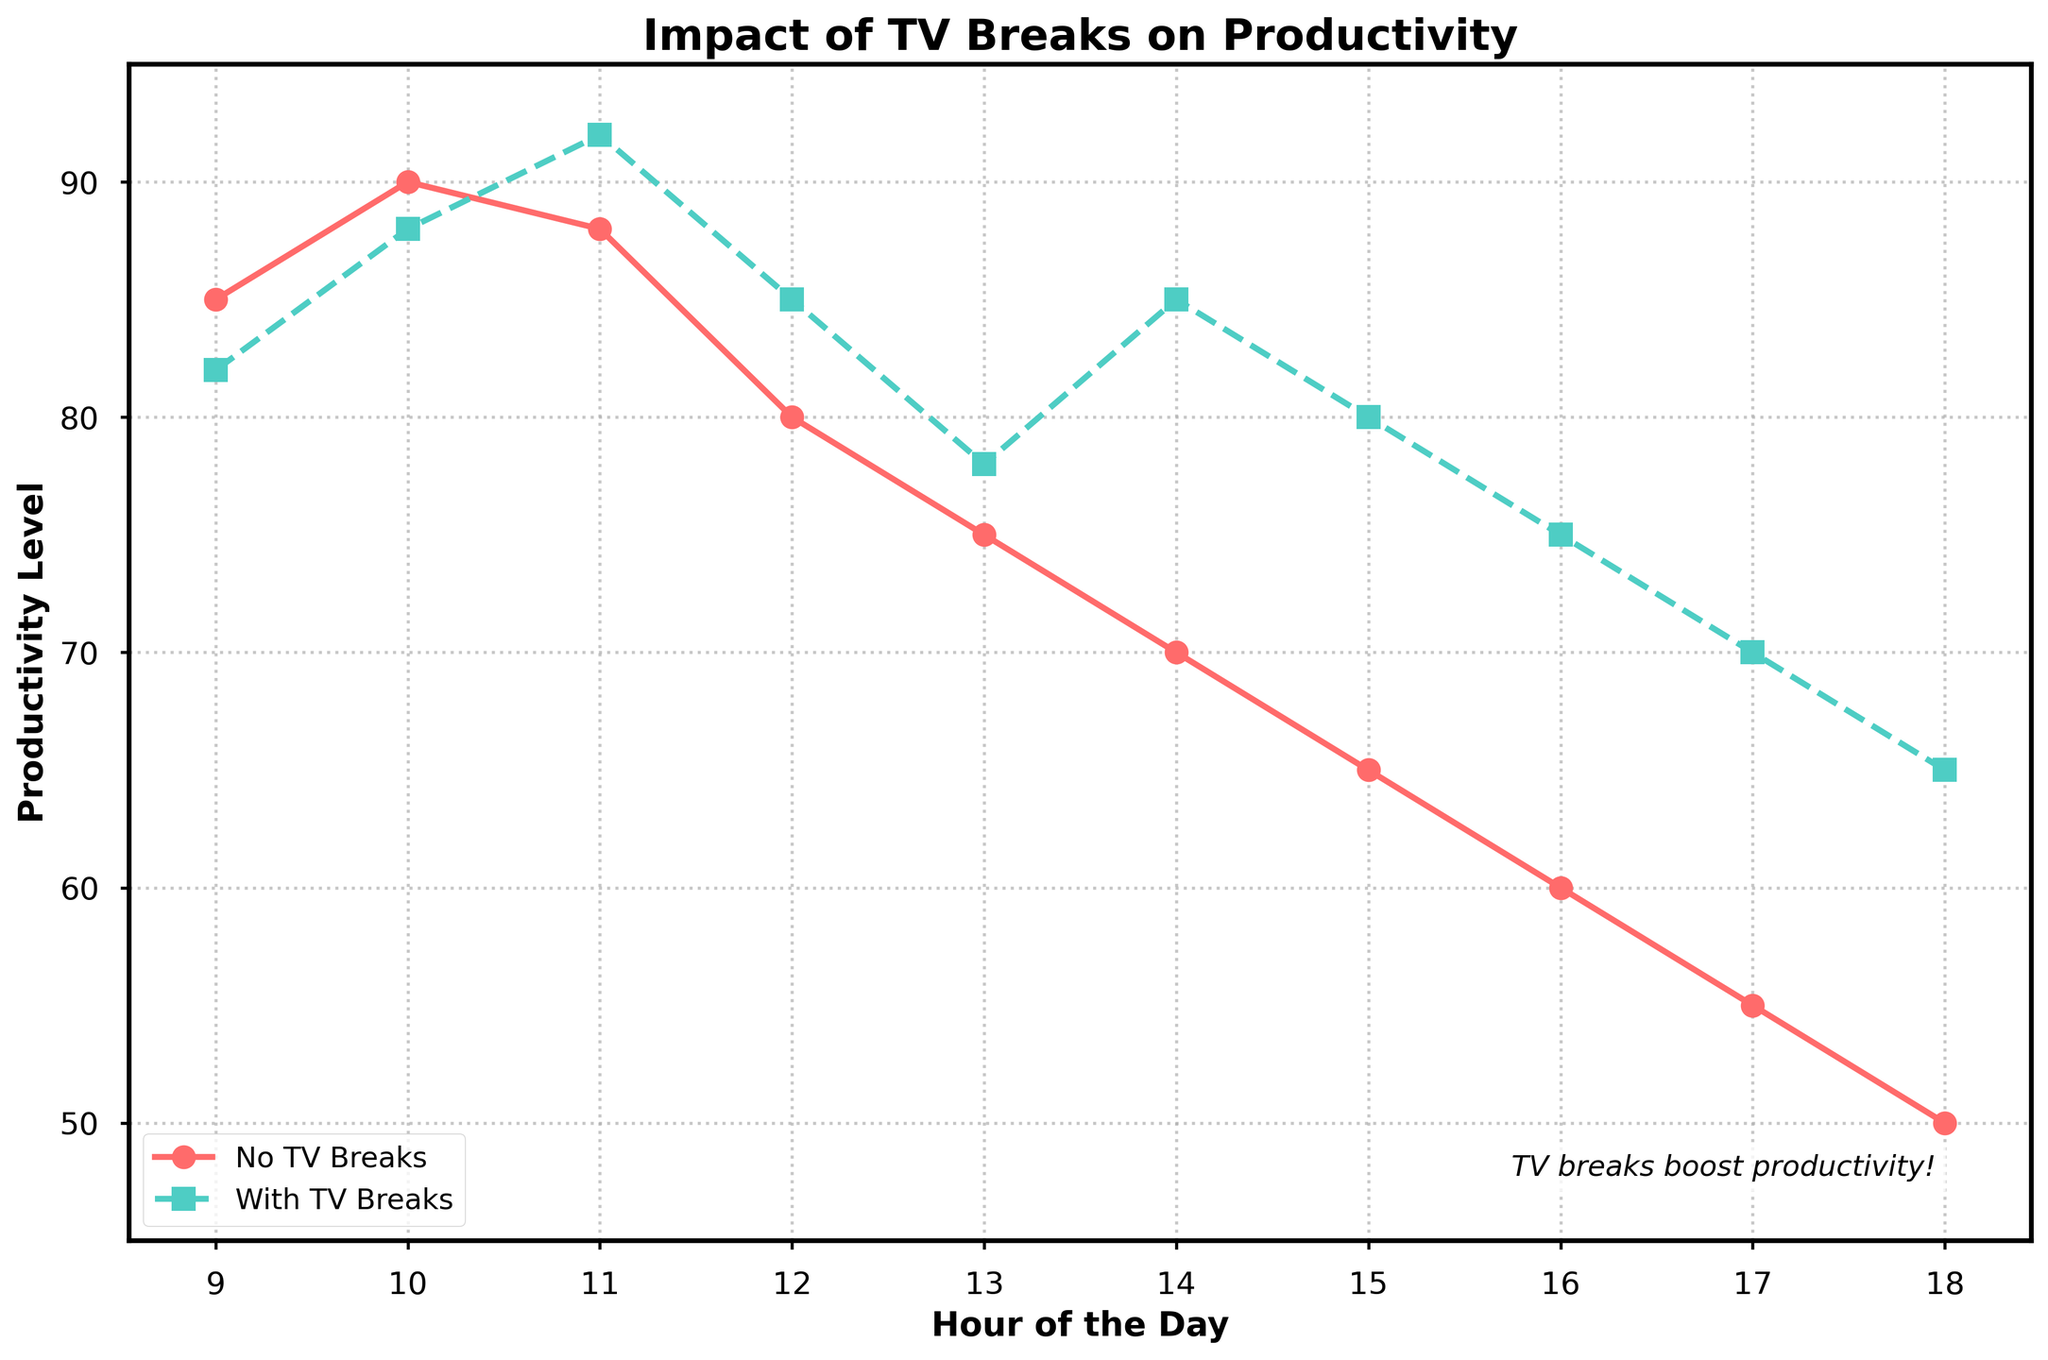What is the productivity level at 12 PM for both scenarios? At 12 PM, the productivity level for "No TV Breaks" is 80, and for "With TV Breaks" is 85.
Answer: No Breaks: 80, With Breaks: 85 How does the productivity level change from 10 AM to 11 AM with TV breaks? For "With TV Breaks", the productivity level changes from 88 at 10 AM to 92 at 11 AM. The change is 92 - 88 = 4.
Answer: Increases by 4 Which hour shows the greatest difference in productivity between no TV breaks and with TV breaks? At 2 PM, the productivity with TV breaks is 85 compared to 70 without breaks, resulting in the greatest difference of 85 - 70 = 15
Answer: 2 PM Compare the trends in productivity levels from 1 PM to 3 PM for both scenarios. From 1 PM to 3 PM, productivity levels for "No TV Breaks" drop from 75 to 65, declining by 10, while for "With TV Breaks", they increase from 78 to 85, an increase of 7.
Answer: No Breaks: Decreases, With Breaks: Increases At which time does productivity level consistently start dropping in both scenarios? The productivity level consistently starts dropping from 10 AM to 11 AM onwards for both scenarios, particularly noticeable after 11 AM.
Answer: 11 AM What is the average productivity level at 9 AM, 1 PM, and 5 PM without TV breaks? The values are 85 at 9 AM, 75 at 1 PM, and 55 at 5 PM. The average is (85 + 75 + 55) / 3 = 71.67
Answer: 71.67 Between 3 PM and 5 PM, which scenario shows a higher productivity level, and by how much? At 3 PM, productivity is 80 (with breaks) vs. 65 (no breaks). At 4 PM, it’s 75 vs. 60. At 5 PM, it’s 70 vs. 55. The differences are 80 - 65 = 15, 75 - 60 = 15, and 70 - 55 = 15. So, "With TV Breaks" has a consistently higher productivity by 15 points in this interval.
Answer: With TV Breaks by 15 What is the productivity level at 3 PM for both scenarios? At 3 PM, the productivity level for "No TV Breaks" is 65, and for "With TV Breaks" is 80.
Answer: No Breaks: 65, With Breaks: 80 By how much does productivity decrease from 9 AM to 6 PM with and without TV breaks? From 9 AM to 6 PM, the productivity without TV breaks decreases from 85 to 50, which is a decrease of 85 - 50 = 35. For "With TV Breaks," it decreases from 82 to 65, which is a decrease of 82 - 65 = 17.
Answer: No Breaks: 35, With Breaks: 17 